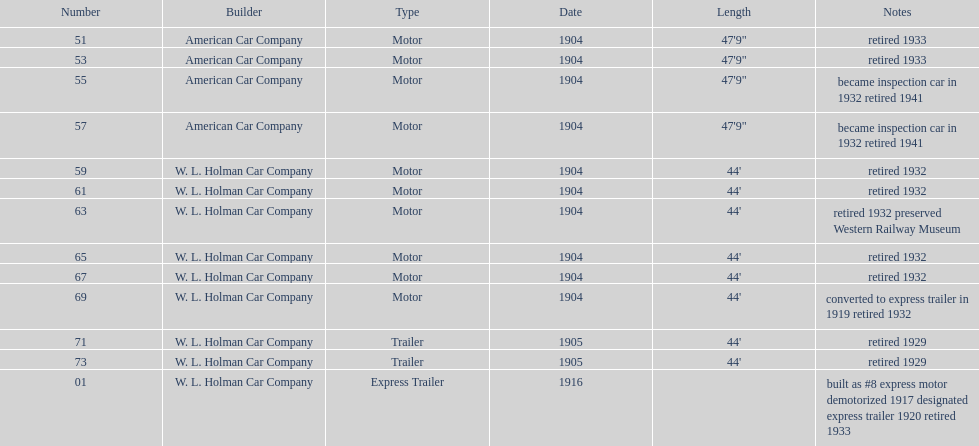How long did it take number 71 to retire? 24. 